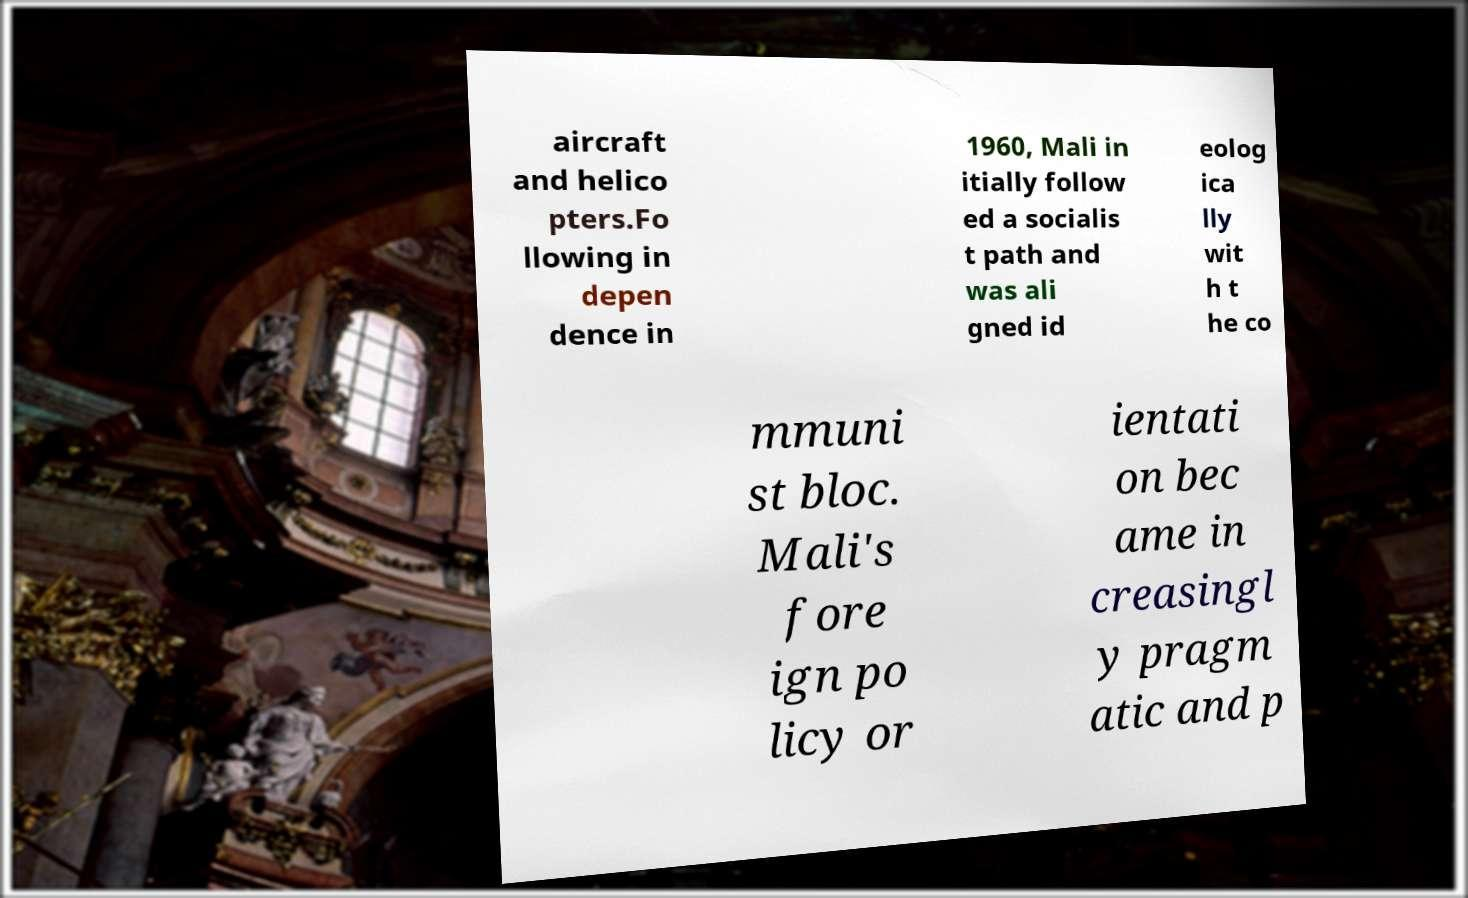Can you accurately transcribe the text from the provided image for me? aircraft and helico pters.Fo llowing in depen dence in 1960, Mali in itially follow ed a socialis t path and was ali gned id eolog ica lly wit h t he co mmuni st bloc. Mali's fore ign po licy or ientati on bec ame in creasingl y pragm atic and p 